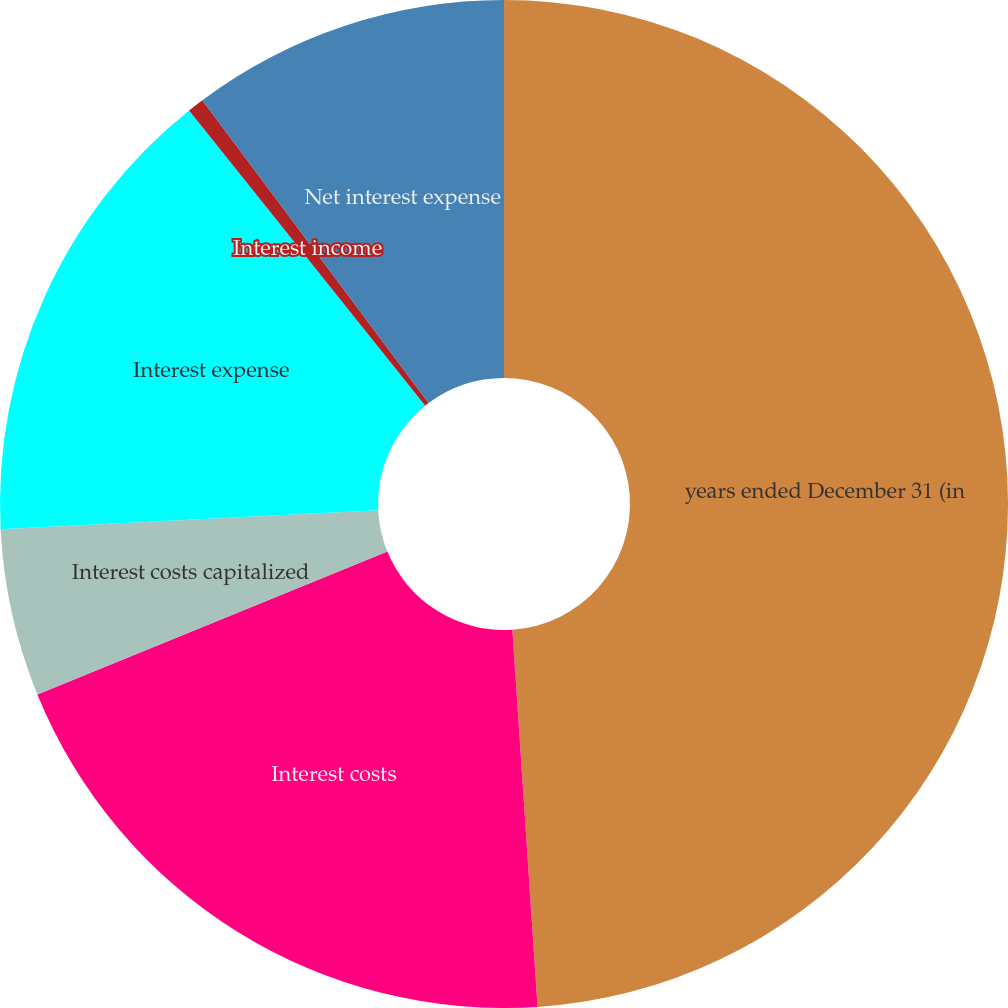<chart> <loc_0><loc_0><loc_500><loc_500><pie_chart><fcel>years ended December 31 (in<fcel>Interest costs<fcel>Interest costs capitalized<fcel>Interest expense<fcel>Interest income<fcel>Net interest expense<nl><fcel>48.93%<fcel>19.89%<fcel>5.37%<fcel>15.05%<fcel>0.53%<fcel>10.21%<nl></chart> 